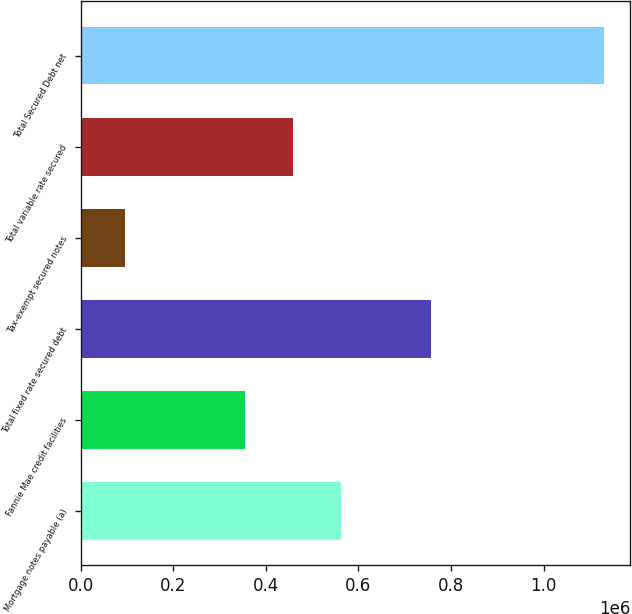<chart> <loc_0><loc_0><loc_500><loc_500><bar_chart><fcel>Mortgage notes payable (a)<fcel>Fannie Mae credit facilities<fcel>Total fixed rate secured debt<fcel>Tax-exempt secured notes<fcel>Total variable rate secured<fcel>Total Secured Debt net<nl><fcel>563068<fcel>355836<fcel>756151<fcel>94700<fcel>459452<fcel>1.13086e+06<nl></chart> 